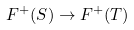<formula> <loc_0><loc_0><loc_500><loc_500>F ^ { + } ( S ) \to F ^ { + } ( T )</formula> 